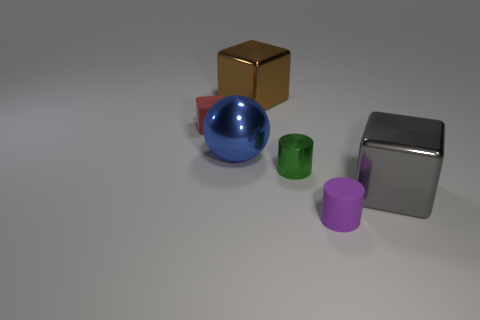Add 2 brown metal objects. How many objects exist? 8 Subtract all spheres. How many objects are left? 5 Add 3 large blue metal objects. How many large blue metal objects are left? 4 Add 2 big red spheres. How many big red spheres exist? 2 Subtract 0 yellow cylinders. How many objects are left? 6 Subtract all small shiny objects. Subtract all big gray blocks. How many objects are left? 4 